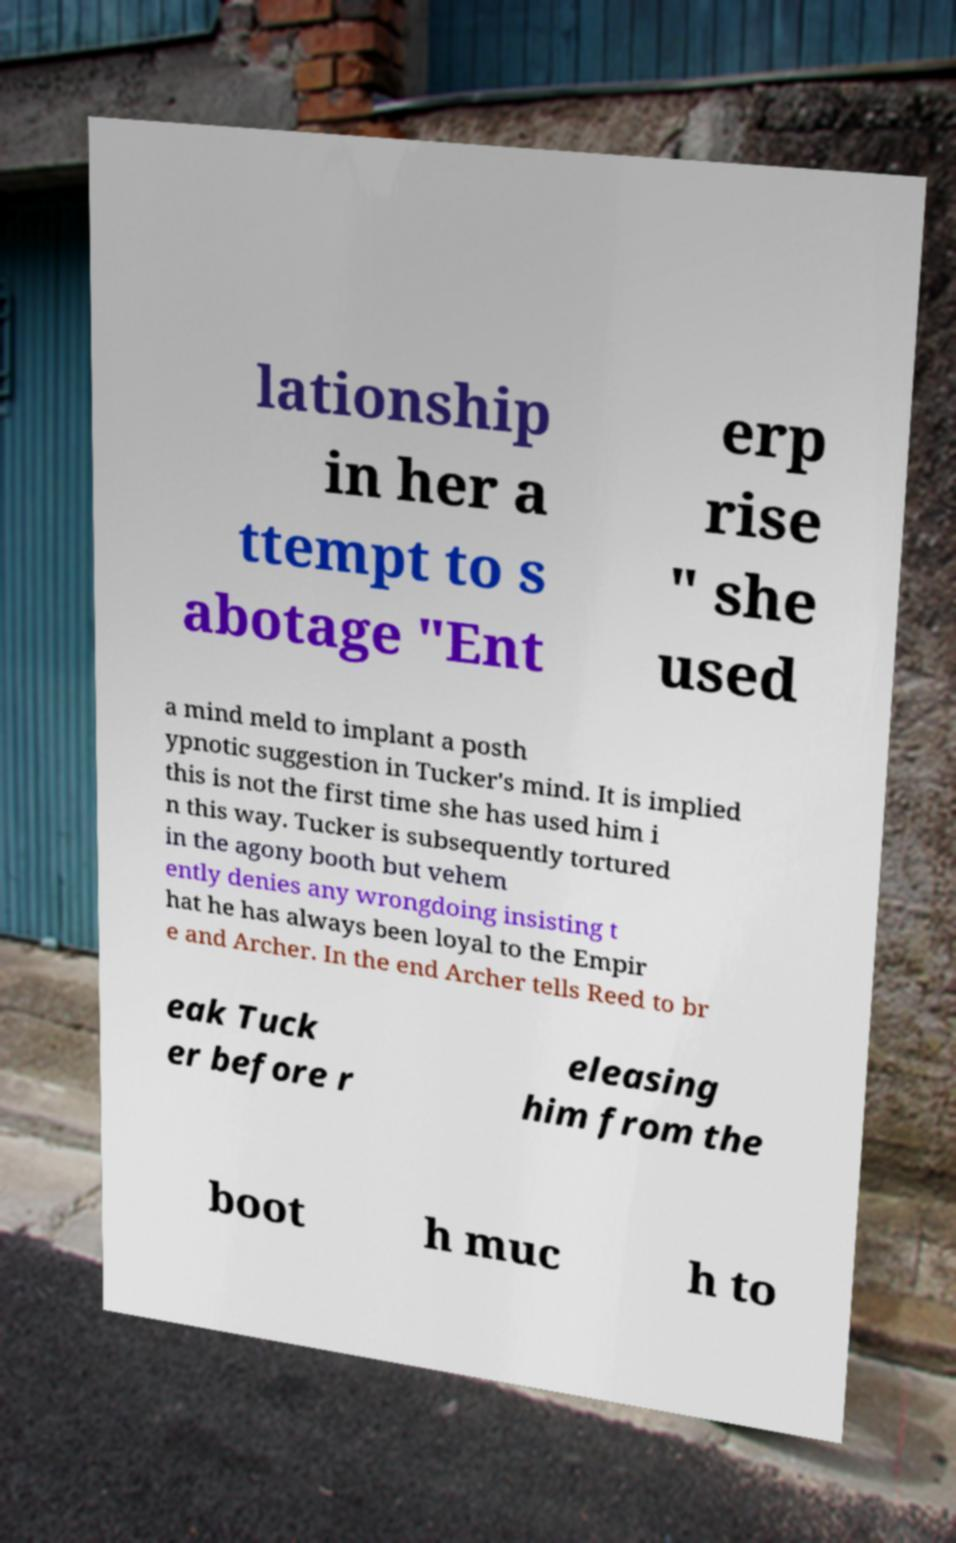Please identify and transcribe the text found in this image. lationship in her a ttempt to s abotage "Ent erp rise " she used a mind meld to implant a posth ypnotic suggestion in Tucker's mind. It is implied this is not the first time she has used him i n this way. Tucker is subsequently tortured in the agony booth but vehem ently denies any wrongdoing insisting t hat he has always been loyal to the Empir e and Archer. In the end Archer tells Reed to br eak Tuck er before r eleasing him from the boot h muc h to 